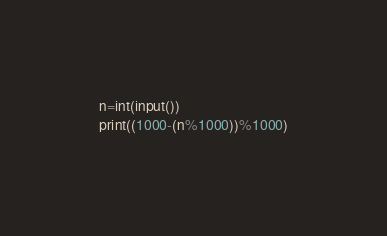<code> <loc_0><loc_0><loc_500><loc_500><_Python_>n=int(input())
print((1000-(n%1000))%1000)</code> 